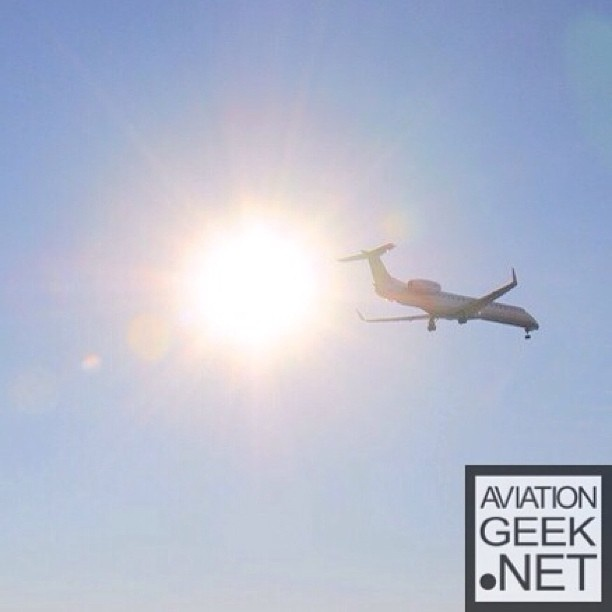Describe the objects in this image and their specific colors. I can see a airplane in gray, darkgray, tan, and lightgray tones in this image. 